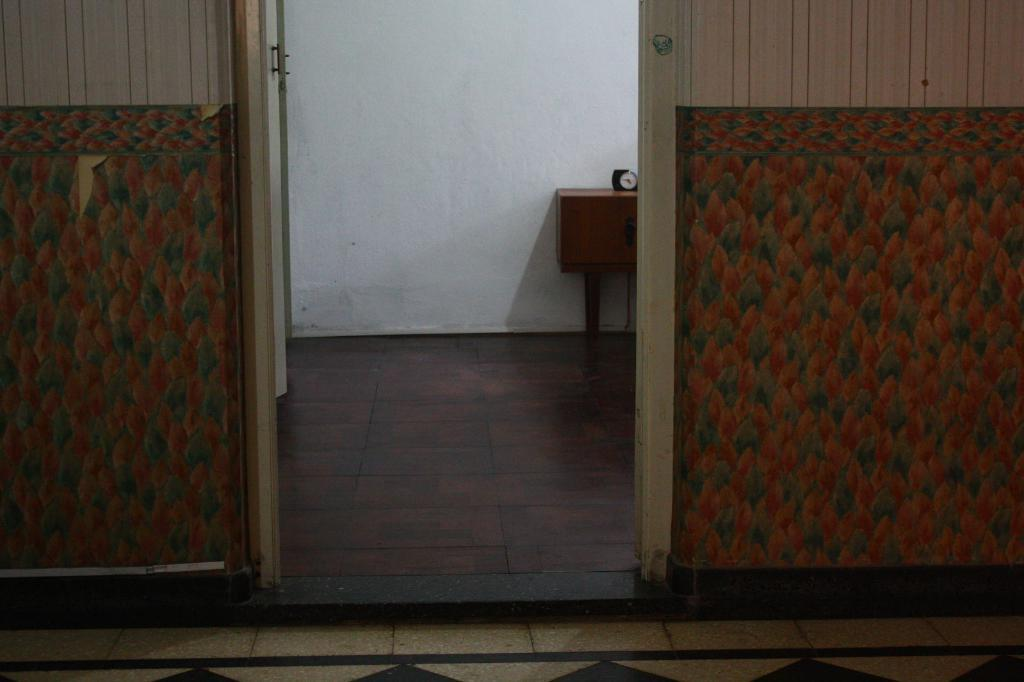What type of structure can be seen in the image? There are walls in the image. Can you describe the door in the image? There is an open door in the middle of the wall. What object is present on a wooden table in the room? There is a clock on a wooden table in the room. What is behind the table in the image? There is a wall behind the table. What type of crackers are being served to the friend in the image? There is no friend or crackers present in the image. How many cakes are on the table in the image? There are no cakes present in the image. 